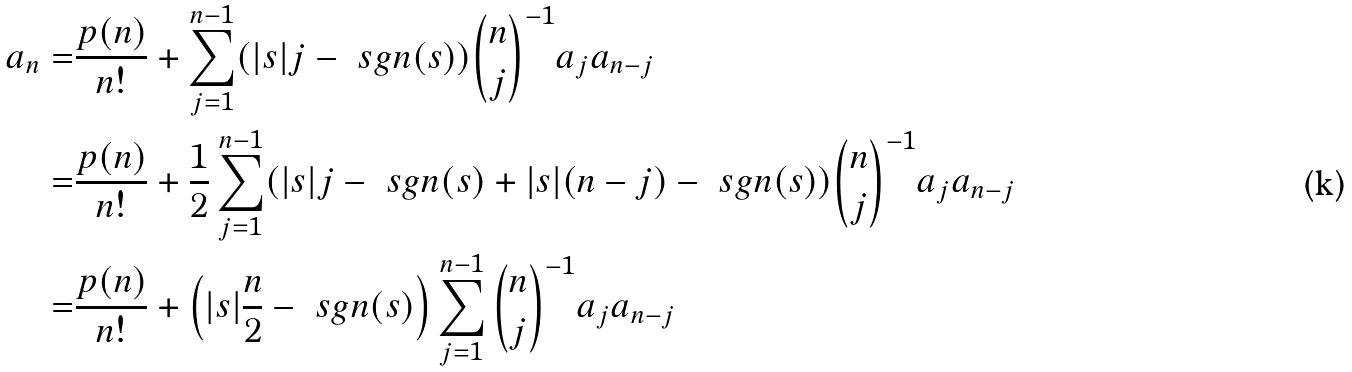<formula> <loc_0><loc_0><loc_500><loc_500>a _ { n } = & \frac { p ( n ) } { n ! } + \sum _ { j = 1 } ^ { n - 1 } ( | s | j - \ s g n ( s ) ) \binom { n } { j } ^ { - 1 } a _ { j } a _ { n - j } \\ = & \frac { p ( n ) } { n ! } + \frac { 1 } { 2 } \sum _ { j = 1 } ^ { n - 1 } ( | s | j - \ s g n ( s ) + | s | ( n - j ) - \ s g n ( s ) ) \binom { n } { j } ^ { - 1 } a _ { j } a _ { n - j } \\ = & \frac { p ( n ) } { n ! } + \left ( | s | \frac { n } { 2 } - \ s g n ( s ) \right ) \sum _ { j = 1 } ^ { n - 1 } \binom { n } { j } ^ { - 1 } a _ { j } a _ { n - j }</formula> 